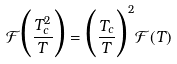<formula> <loc_0><loc_0><loc_500><loc_500>\mathcal { F } \Big { ( } \frac { T _ { c } ^ { 2 } } { T } \Big { ) } = \Big { ( } \frac { T _ { c } } { T } \Big { ) } ^ { 2 } \mathcal { F } ( T )</formula> 